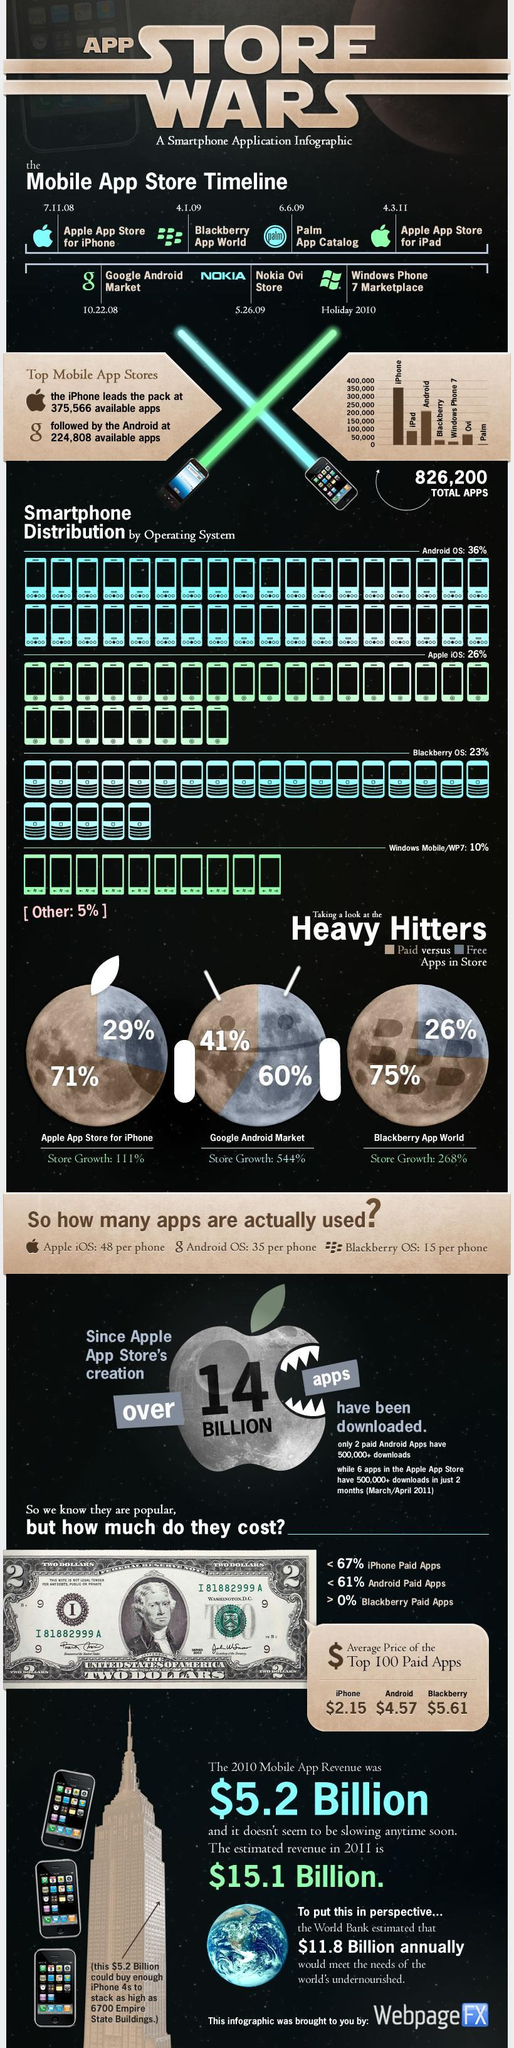What is the percentage of free apps in the iPhone and android store, taken together?
Answer the question with a short phrase. 89% What is the percentage distribution of Blackberry OS and Windows mobile, taken together? 33% What is the difference between the percentage store growth of Android and the iPhone? 433% What is the percentage of paid apps on the iPhone and android store, taken together? 112% What is the percentage distribution of Android OS and Apple IOS, taken together? 62% What is the difference between the percentage store growth of Android and the Blackberry? 276% 